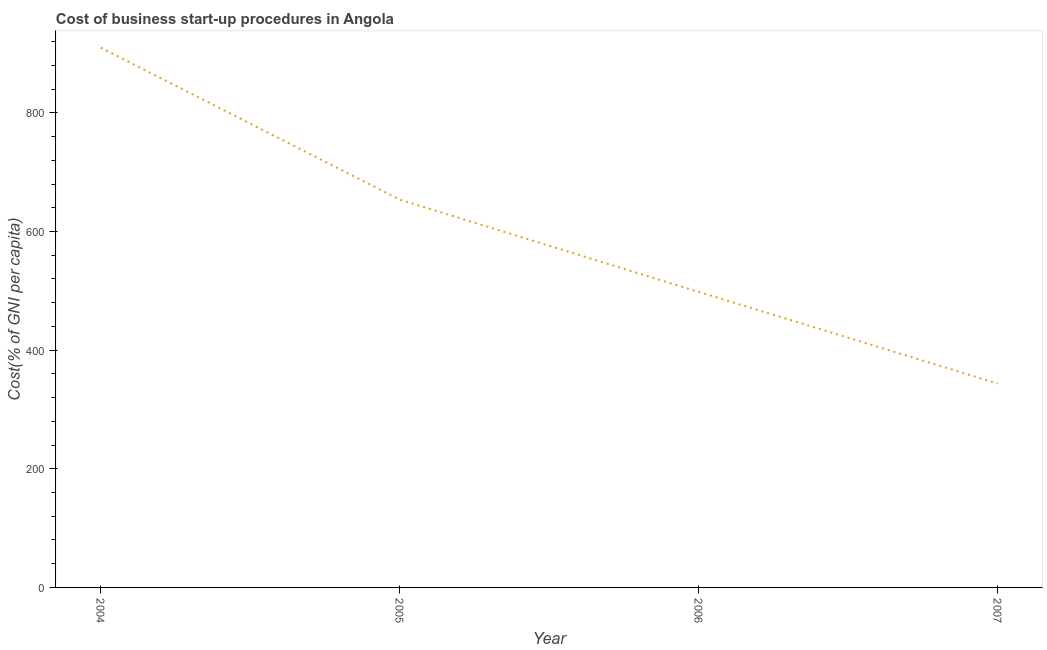What is the cost of business startup procedures in 2006?
Provide a succinct answer. 498.2. Across all years, what is the maximum cost of business startup procedures?
Keep it short and to the point. 910. Across all years, what is the minimum cost of business startup procedures?
Provide a succinct answer. 343.7. In which year was the cost of business startup procedures maximum?
Make the answer very short. 2004. In which year was the cost of business startup procedures minimum?
Your answer should be very brief. 2007. What is the sum of the cost of business startup procedures?
Keep it short and to the point. 2405.7. What is the difference between the cost of business startup procedures in 2006 and 2007?
Keep it short and to the point. 154.5. What is the average cost of business startup procedures per year?
Offer a very short reply. 601.42. What is the median cost of business startup procedures?
Provide a short and direct response. 576. In how many years, is the cost of business startup procedures greater than 800 %?
Ensure brevity in your answer.  1. Do a majority of the years between 2004 and 2005 (inclusive) have cost of business startup procedures greater than 240 %?
Provide a short and direct response. Yes. What is the ratio of the cost of business startup procedures in 2005 to that in 2007?
Keep it short and to the point. 1.9. Is the difference between the cost of business startup procedures in 2005 and 2006 greater than the difference between any two years?
Your response must be concise. No. What is the difference between the highest and the second highest cost of business startup procedures?
Your answer should be compact. 256.2. Is the sum of the cost of business startup procedures in 2005 and 2007 greater than the maximum cost of business startup procedures across all years?
Keep it short and to the point. Yes. What is the difference between the highest and the lowest cost of business startup procedures?
Provide a short and direct response. 566.3. In how many years, is the cost of business startup procedures greater than the average cost of business startup procedures taken over all years?
Ensure brevity in your answer.  2. Are the values on the major ticks of Y-axis written in scientific E-notation?
Give a very brief answer. No. Does the graph contain grids?
Your response must be concise. No. What is the title of the graph?
Offer a very short reply. Cost of business start-up procedures in Angola. What is the label or title of the X-axis?
Make the answer very short. Year. What is the label or title of the Y-axis?
Offer a very short reply. Cost(% of GNI per capita). What is the Cost(% of GNI per capita) of 2004?
Make the answer very short. 910. What is the Cost(% of GNI per capita) in 2005?
Provide a succinct answer. 653.8. What is the Cost(% of GNI per capita) in 2006?
Offer a terse response. 498.2. What is the Cost(% of GNI per capita) of 2007?
Provide a short and direct response. 343.7. What is the difference between the Cost(% of GNI per capita) in 2004 and 2005?
Keep it short and to the point. 256.2. What is the difference between the Cost(% of GNI per capita) in 2004 and 2006?
Ensure brevity in your answer.  411.8. What is the difference between the Cost(% of GNI per capita) in 2004 and 2007?
Give a very brief answer. 566.3. What is the difference between the Cost(% of GNI per capita) in 2005 and 2006?
Your answer should be very brief. 155.6. What is the difference between the Cost(% of GNI per capita) in 2005 and 2007?
Offer a terse response. 310.1. What is the difference between the Cost(% of GNI per capita) in 2006 and 2007?
Offer a terse response. 154.5. What is the ratio of the Cost(% of GNI per capita) in 2004 to that in 2005?
Provide a succinct answer. 1.39. What is the ratio of the Cost(% of GNI per capita) in 2004 to that in 2006?
Provide a succinct answer. 1.83. What is the ratio of the Cost(% of GNI per capita) in 2004 to that in 2007?
Provide a succinct answer. 2.65. What is the ratio of the Cost(% of GNI per capita) in 2005 to that in 2006?
Give a very brief answer. 1.31. What is the ratio of the Cost(% of GNI per capita) in 2005 to that in 2007?
Your answer should be very brief. 1.9. What is the ratio of the Cost(% of GNI per capita) in 2006 to that in 2007?
Provide a short and direct response. 1.45. 